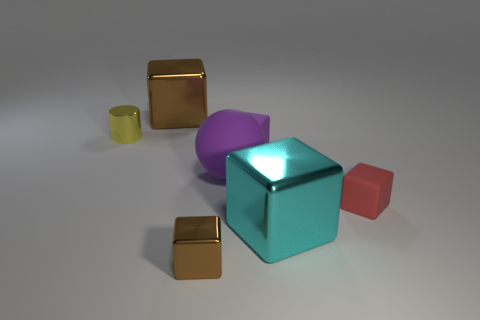Is the size of the shiny cylinder the same as the brown object that is behind the tiny purple matte thing? The size of the shiny cylinder is not the same as the brown object; the cylinder appears significantly smaller and possesses a different shape. 